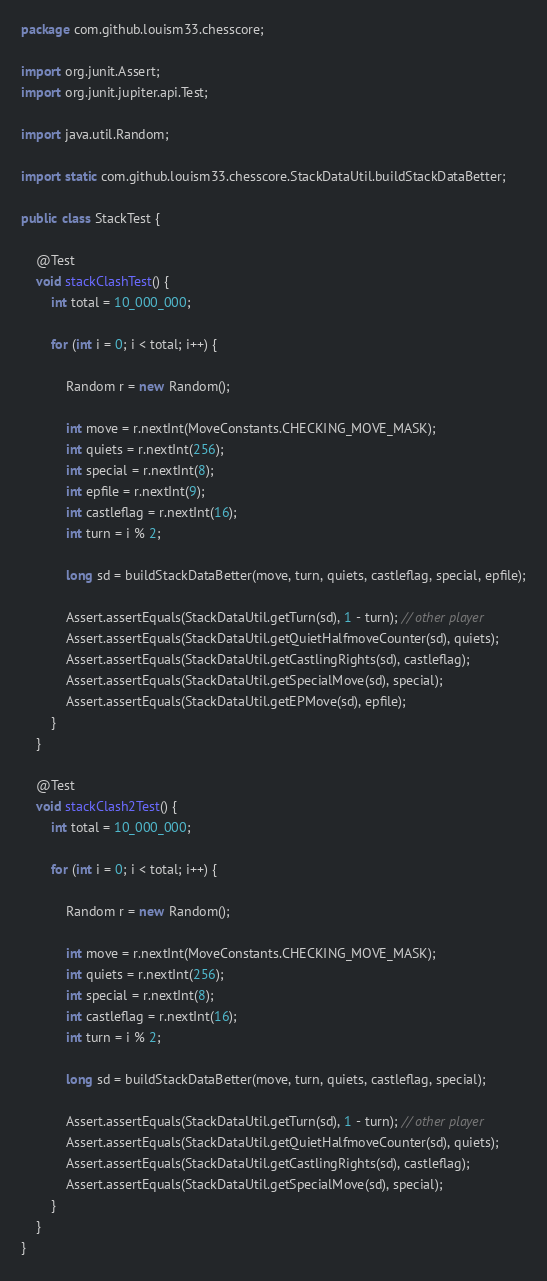Convert code to text. <code><loc_0><loc_0><loc_500><loc_500><_Java_>package com.github.louism33.chesscore;

import org.junit.Assert;
import org.junit.jupiter.api.Test;

import java.util.Random;

import static com.github.louism33.chesscore.StackDataUtil.buildStackDataBetter;

public class StackTest {

    @Test
    void stackClashTest() {
        int total = 10_000_000;

        for (int i = 0; i < total; i++) {

            Random r = new Random();

            int move = r.nextInt(MoveConstants.CHECKING_MOVE_MASK);
            int quiets = r.nextInt(256);
            int special = r.nextInt(8);
            int epfile = r.nextInt(9);
            int castleflag = r.nextInt(16);
            int turn = i % 2;

            long sd = buildStackDataBetter(move, turn, quiets, castleflag, special, epfile);
            
            Assert.assertEquals(StackDataUtil.getTurn(sd), 1 - turn); // other player
            Assert.assertEquals(StackDataUtil.getQuietHalfmoveCounter(sd), quiets);
            Assert.assertEquals(StackDataUtil.getCastlingRights(sd), castleflag);
            Assert.assertEquals(StackDataUtil.getSpecialMove(sd), special);
            Assert.assertEquals(StackDataUtil.getEPMove(sd), epfile);
        }
    }

    @Test
    void stackClash2Test() {
        int total = 10_000_000;

        for (int i = 0; i < total; i++) {

            Random r = new Random();

            int move = r.nextInt(MoveConstants.CHECKING_MOVE_MASK);
            int quiets = r.nextInt(256);
            int special = r.nextInt(8);
            int castleflag = r.nextInt(16);
            int turn = i % 2;

            long sd = buildStackDataBetter(move, turn, quiets, castleflag, special);

            Assert.assertEquals(StackDataUtil.getTurn(sd), 1 - turn); // other player
            Assert.assertEquals(StackDataUtil.getQuietHalfmoveCounter(sd), quiets);
            Assert.assertEquals(StackDataUtil.getCastlingRights(sd), castleflag);
            Assert.assertEquals(StackDataUtil.getSpecialMove(sd), special);
        }
    }
}</code> 